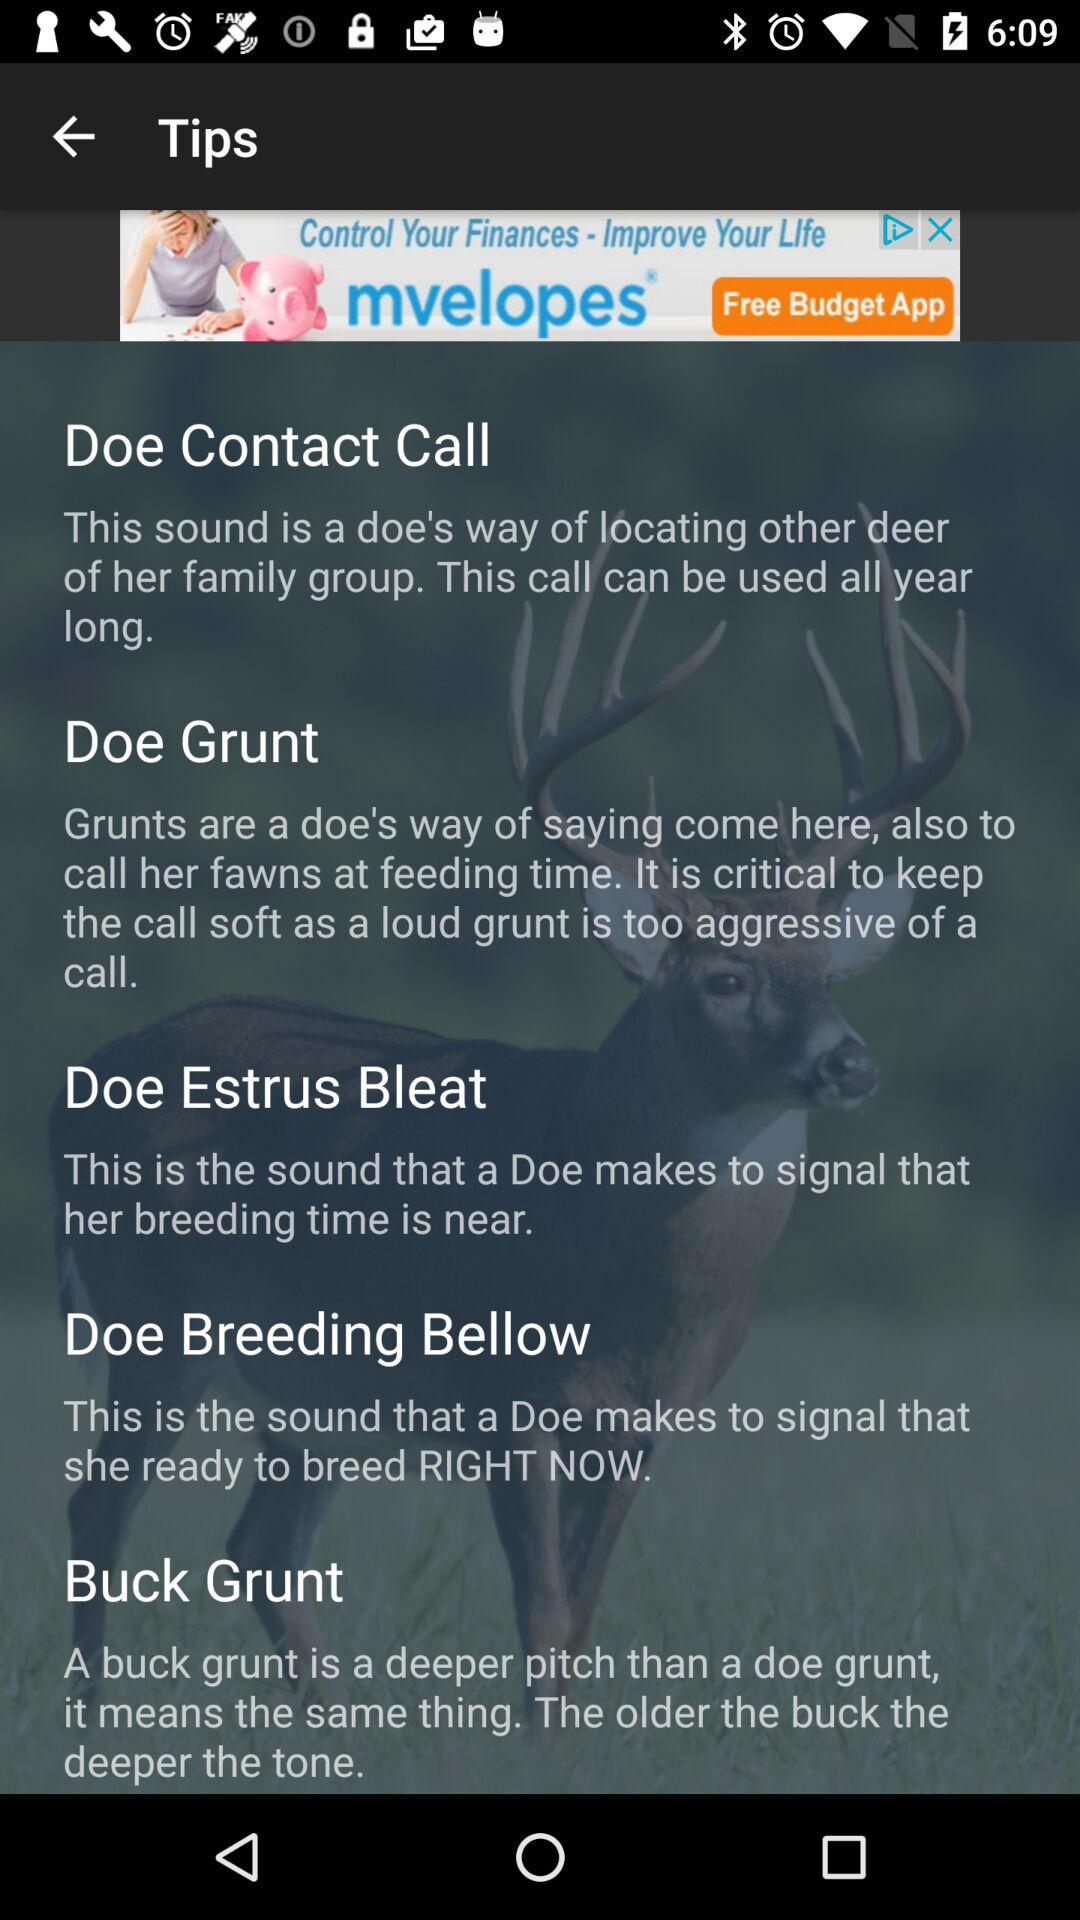How many tips are there about deer sounds?
Answer the question using a single word or phrase. 5 